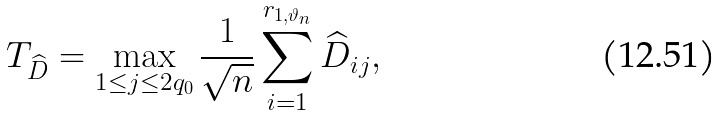<formula> <loc_0><loc_0><loc_500><loc_500>T _ { \widehat { D } } = \max _ { 1 \leq j \leq 2 q _ { 0 } } \frac { 1 } { \sqrt { n } } \sum ^ { r _ { 1 , \vartheta _ { n } } } _ { i = 1 } \widehat { D } _ { i j } ,</formula> 